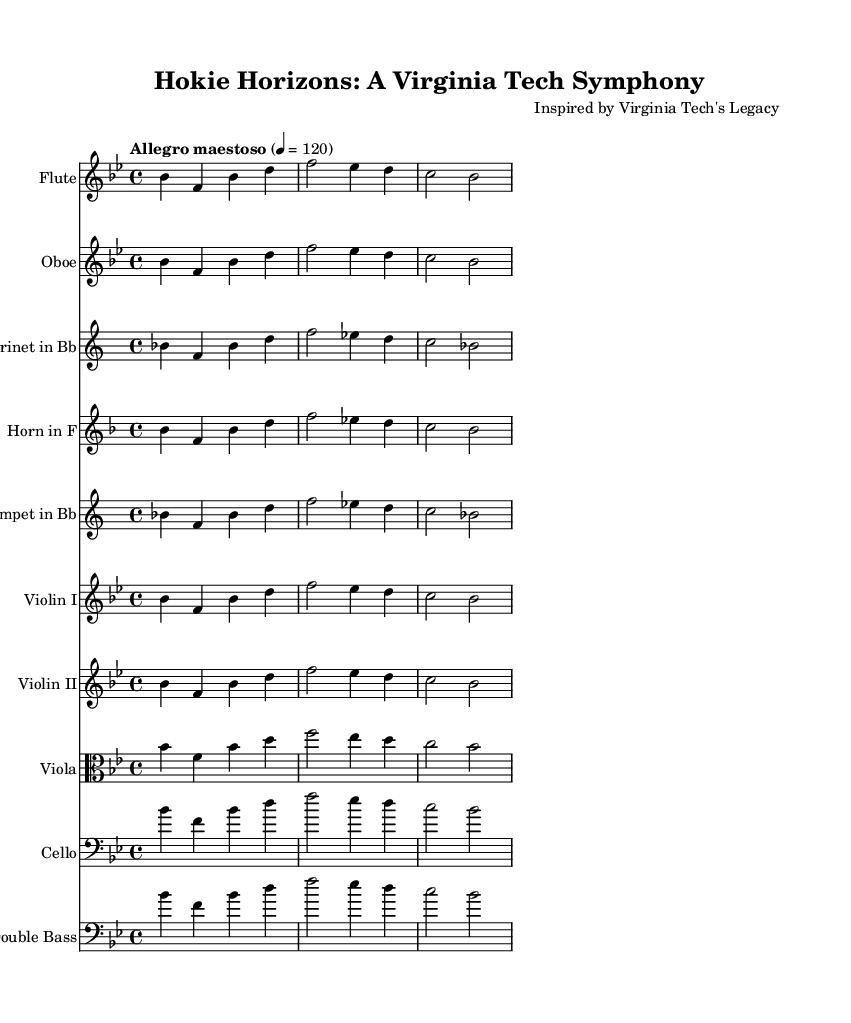What is the key signature of this music? The key signature is B flat major, which has two flats indicated in the key signature: B flat and E flat.
Answer: B flat major What is the time signature of this music? The time signature is 4/4, which shows that there are four beats in each measure. This is indicated at the beginning of the score.
Answer: 4/4 What is the tempo marking? The tempo marking is "Allegro maestoso," which indicates a lively and majestic tempo. The metronome marking is 120 beats per minute.
Answer: Allegro maestoso How many different instruments are featured in the score? The score features ten different instruments, as indicated by the individual staves for each instrument listed above.
Answer: Ten What is the initial note of the main theme for the Flute? The initial note of the main theme for the Flute is B flat, which starts the melody in the specified staff.
Answer: B flat What clef is used for the Viola part? The part for the Viola uses the alto clef, indicated at the beginning of the Viola staff.
Answer: Alto clef Which instrument has a transposed part in the score? The clarinet in B flat has a transposed part, as indicated by the instruction to transpose from B flat to C.
Answer: Clarinet in B flat 